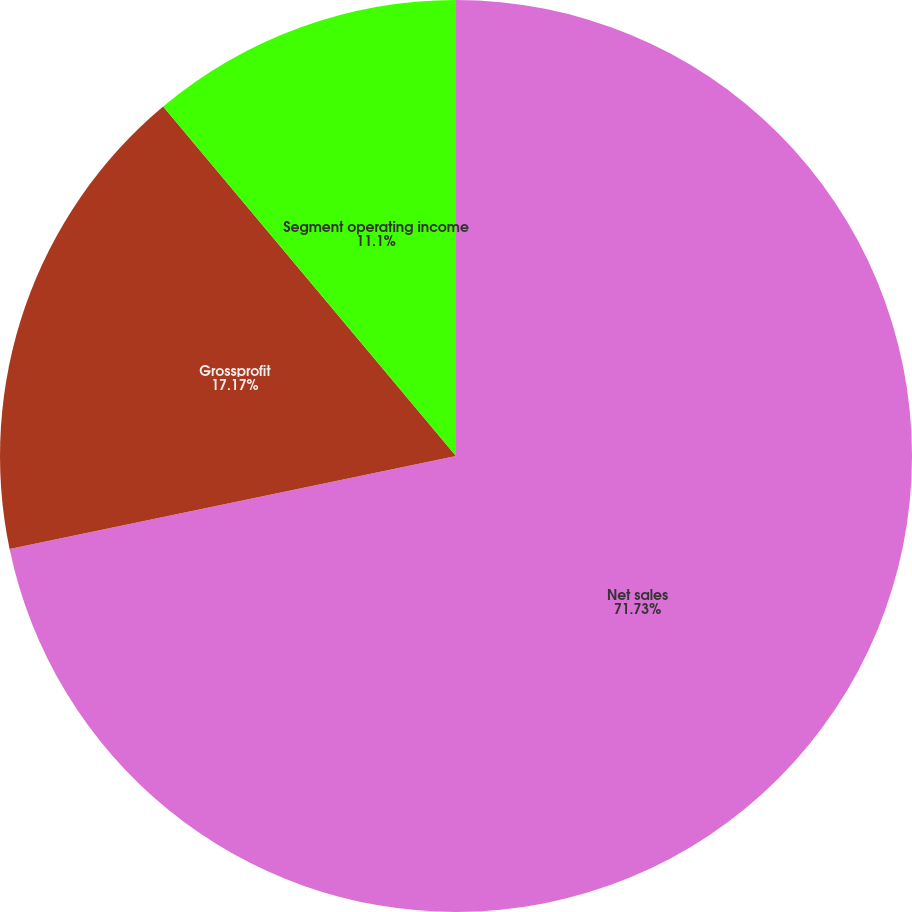Convert chart. <chart><loc_0><loc_0><loc_500><loc_500><pie_chart><fcel>Net sales<fcel>Grossprofit<fcel>Segment operating income<nl><fcel>71.73%<fcel>17.17%<fcel>11.1%<nl></chart> 